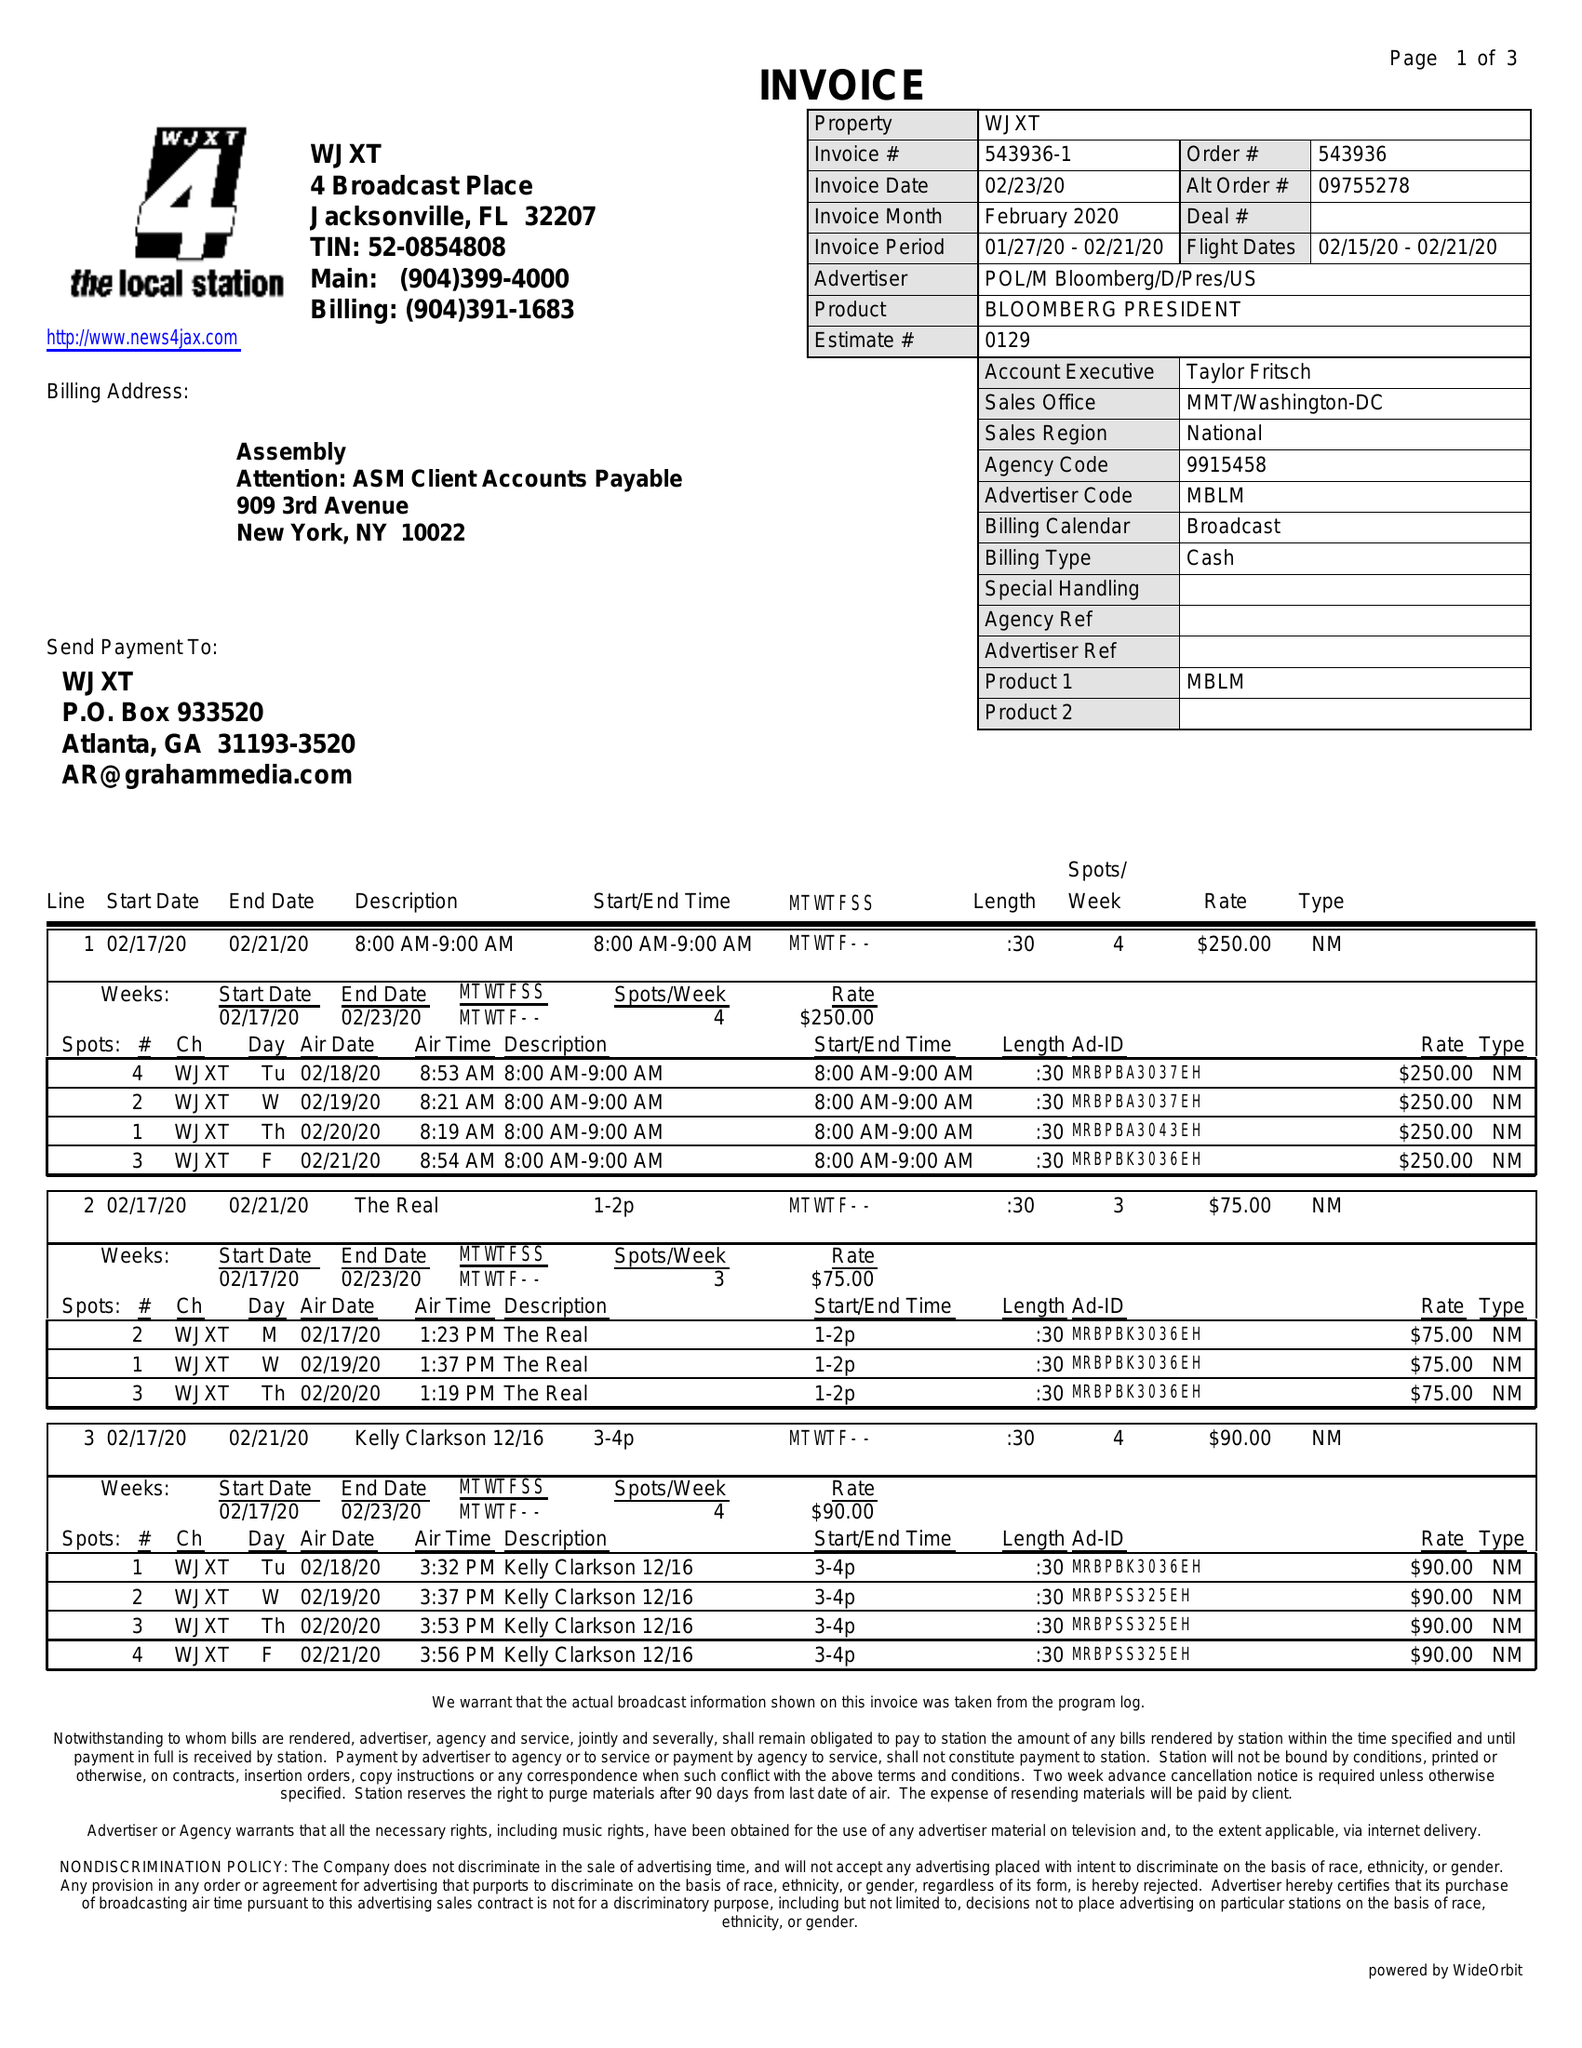What is the value for the gross_amount?
Answer the question using a single word or phrase. 5795.00 